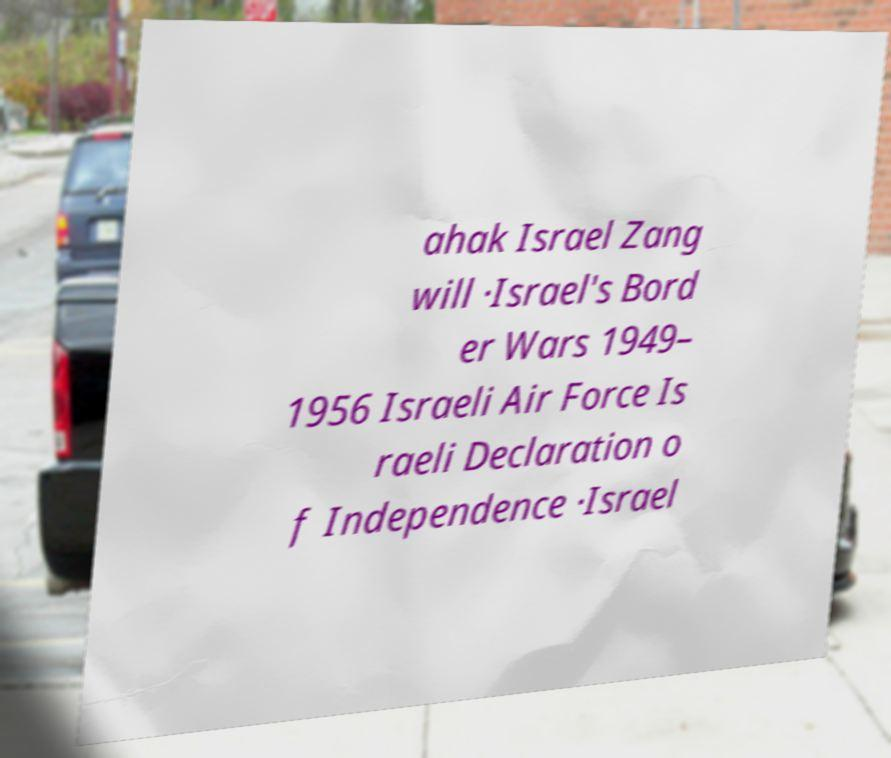Please identify and transcribe the text found in this image. ahak Israel Zang will ·Israel's Bord er Wars 1949– 1956 Israeli Air Force Is raeli Declaration o f Independence ·Israel 